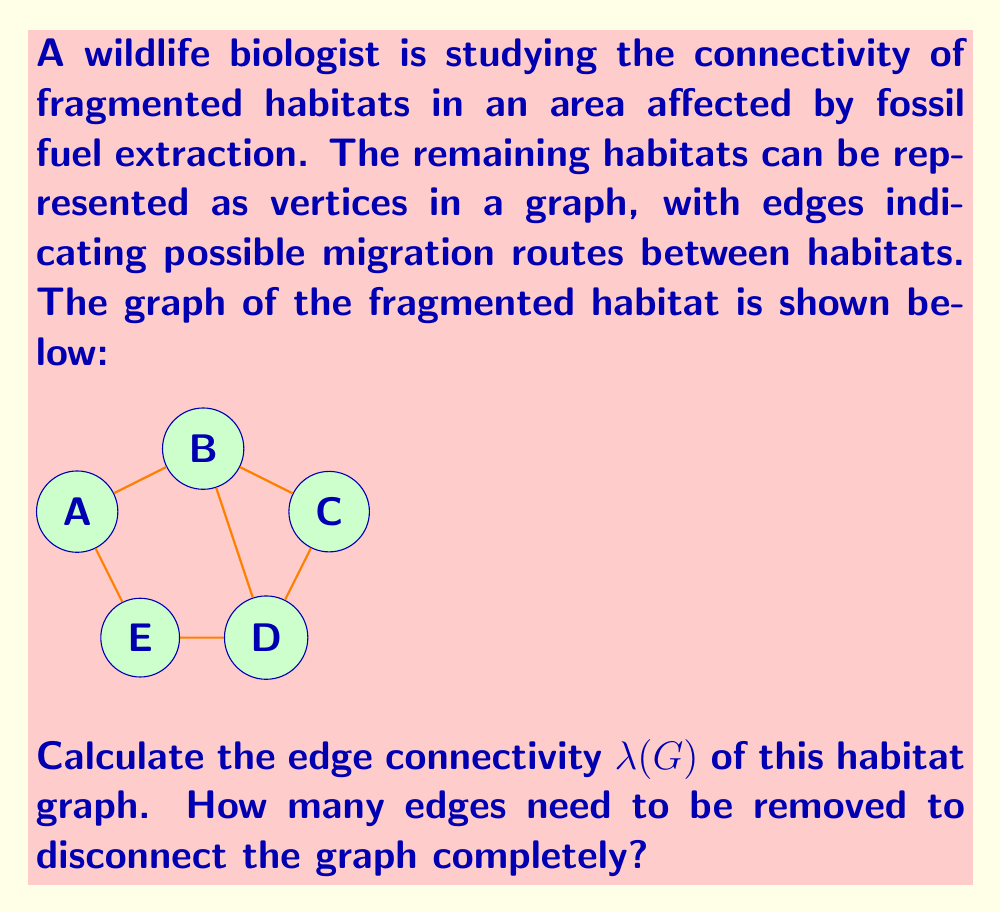What is the answer to this math problem? To solve this problem, we need to understand the concept of edge connectivity in graph theory and apply it to our habitat graph.

1. Edge connectivity $\lambda(G)$ is defined as the minimum number of edges that need to be removed to disconnect the graph.

2. To find $\lambda(G)$, we need to identify the minimum cut set of the graph.

3. Let's analyze the possible cut sets:
   a) Removing edges AB and AE disconnects vertex A from the rest of the graph.
   b) Removing edges BC and BD disconnects vertices A, B, and E from C and D.
   c) Removing edges CD and BD disconnects vertex C from the rest of the graph.
   d) Removing edges DE and BD disconnects vertex D from the rest of the graph.
   e) Removing edges AE and DE disconnects vertex E from the rest of the graph.

4. The minimum number of edges in any of these cut sets is 2.

5. Therefore, the edge connectivity $\lambda(G)$ of this habitat graph is 2.

This means that removing any 2 edges from the specific pairs mentioned above will disconnect the graph, effectively isolating parts of the habitat and preventing migration between them.
Answer: $\lambda(G) = 2$ 